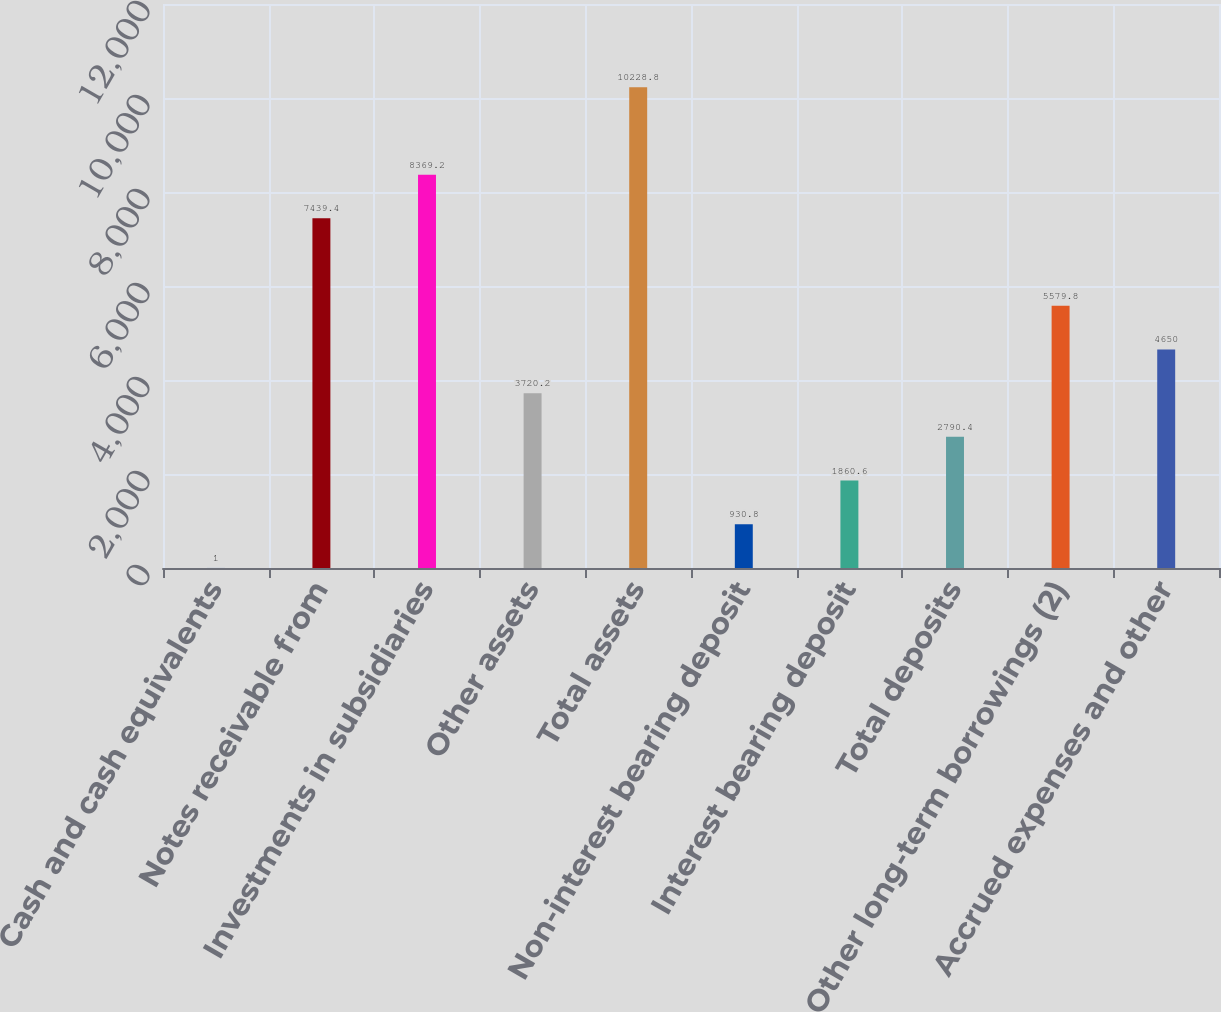Convert chart to OTSL. <chart><loc_0><loc_0><loc_500><loc_500><bar_chart><fcel>Cash and cash equivalents<fcel>Notes receivable from<fcel>Investments in subsidiaries<fcel>Other assets<fcel>Total assets<fcel>Non-interest bearing deposit<fcel>Interest bearing deposit<fcel>Total deposits<fcel>Other long-term borrowings (2)<fcel>Accrued expenses and other<nl><fcel>1<fcel>7439.4<fcel>8369.2<fcel>3720.2<fcel>10228.8<fcel>930.8<fcel>1860.6<fcel>2790.4<fcel>5579.8<fcel>4650<nl></chart> 